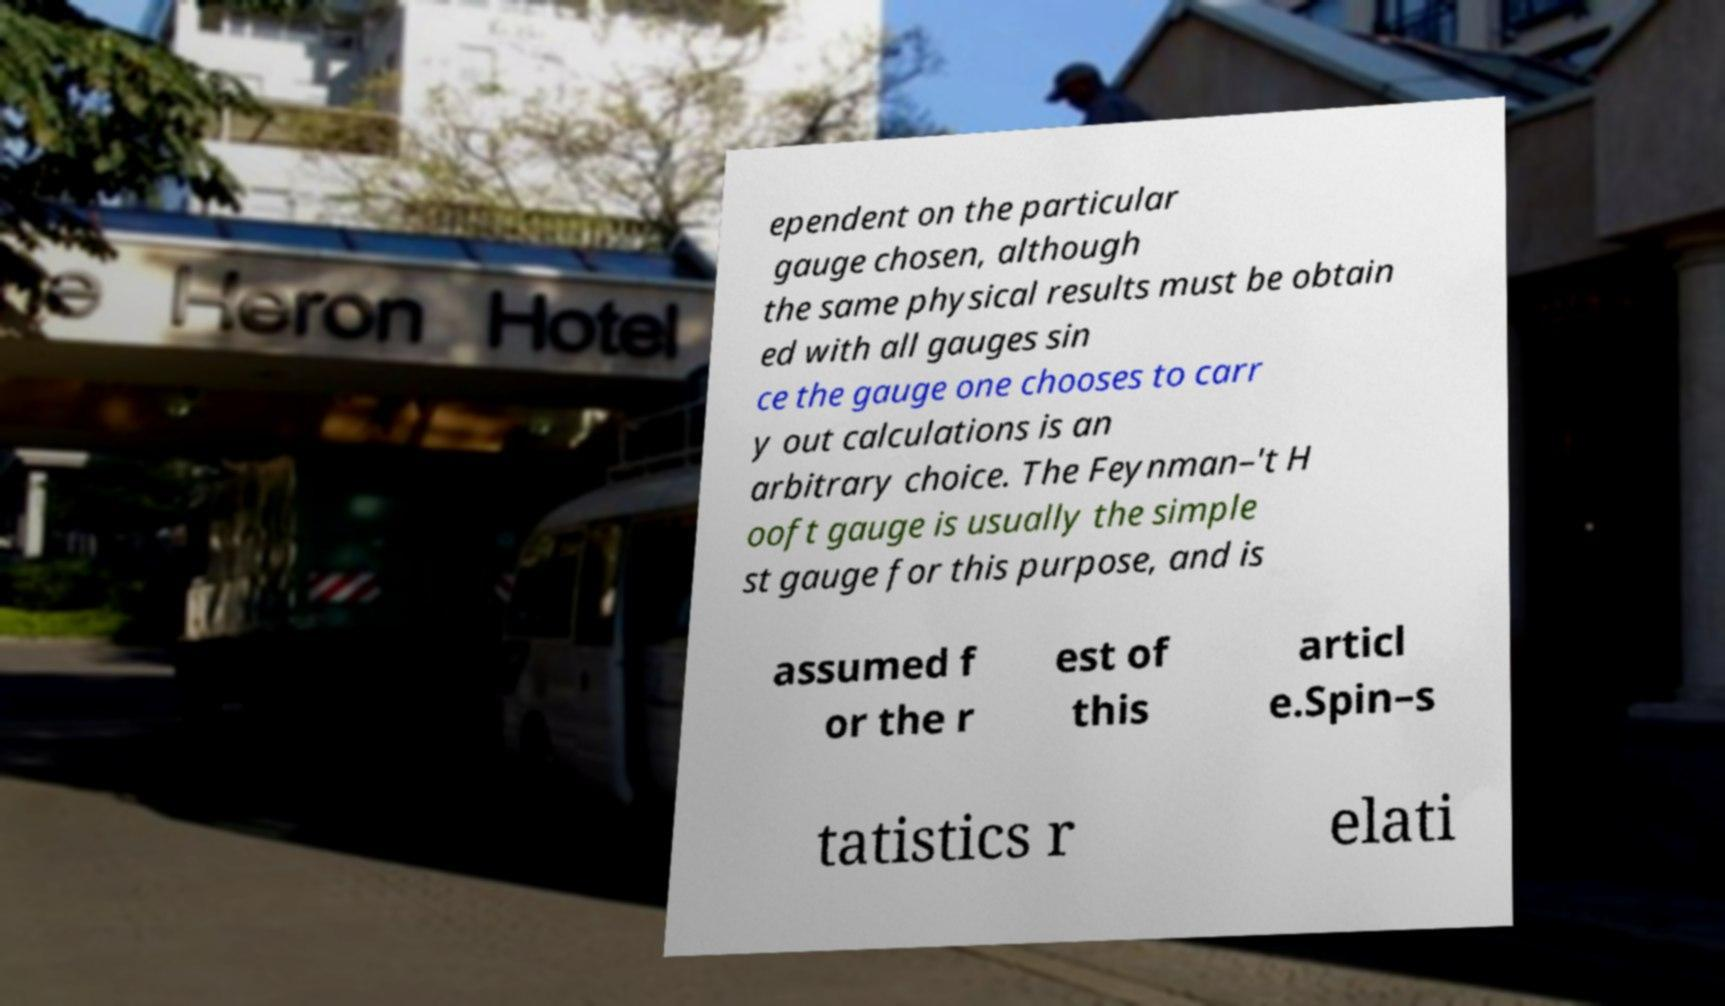Can you read and provide the text displayed in the image?This photo seems to have some interesting text. Can you extract and type it out for me? ependent on the particular gauge chosen, although the same physical results must be obtain ed with all gauges sin ce the gauge one chooses to carr y out calculations is an arbitrary choice. The Feynman–'t H ooft gauge is usually the simple st gauge for this purpose, and is assumed f or the r est of this articl e.Spin–s tatistics r elati 